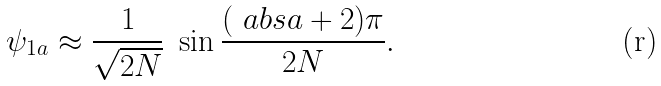<formula> <loc_0><loc_0><loc_500><loc_500>\psi _ { 1 a } \approx \frac { 1 } { \sqrt { 2 N } } \ \sin \frac { ( \ a b s { a } + 2 ) \pi } { 2 N } .</formula> 